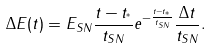Convert formula to latex. <formula><loc_0><loc_0><loc_500><loc_500>\Delta E ( t ) = E _ { S N } \frac { t - t _ { ^ { * } } } { t _ { S N } } e ^ { - \frac { t - t _ { ^ { * } } } { t _ { S N } } } \frac { \Delta t } { t _ { S N } } .</formula> 